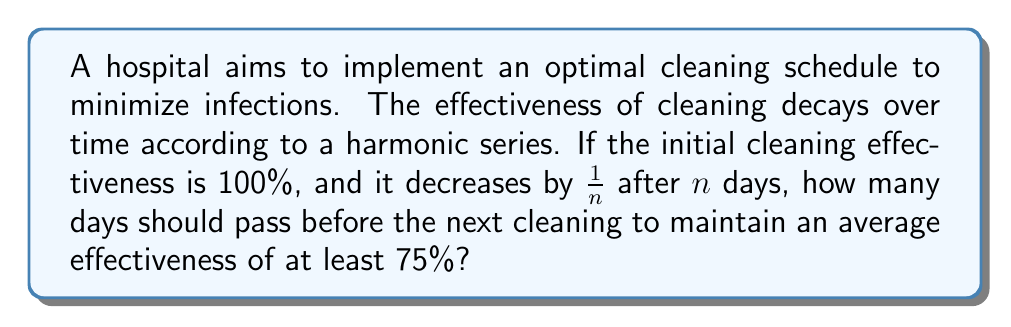Help me with this question. Let's approach this step-by-step:

1) The effectiveness after $n$ days follows the series:

   $$S_n = 1 + \frac{1}{2} + \frac{1}{3} + ... + \frac{1}{n}$$

2) We need to find $n$ such that the average effectiveness is at least 75%:

   $$\frac{S_n}{n} \geq 0.75$$

3) We can use the approximation for the harmonic series:

   $$S_n \approx \ln(n) + \gamma$$

   where $\gamma \approx 0.5772$ is the Euler-Mascheroni constant.

4) Substituting this into our inequality:

   $$\frac{\ln(n) + 0.5772}{n} \geq 0.75$$

5) Solving this numerically (as it's not easily solvable algebraically), we get:

   $$n \approx 3.922$$

6) Since $n$ must be an integer, we round down to 3 to ensure we maintain at least 75% effectiveness.

7) To verify:
   $$S_3 = 1 + \frac{1}{2} + \frac{1}{3} = 1.8333$$
   $$\frac{S_3}{3} = 0.6111 < 0.75$$
   $$S_4 = 1 + \frac{1}{2} + \frac{1}{3} + \frac{1}{4} = 2.0833$$
   $$\frac{S_4}{4} = 0.5208 < 0.75$$

Therefore, cleaning should occur every 3 days to maintain an average effectiveness of at least 75%.
Answer: 3 days 